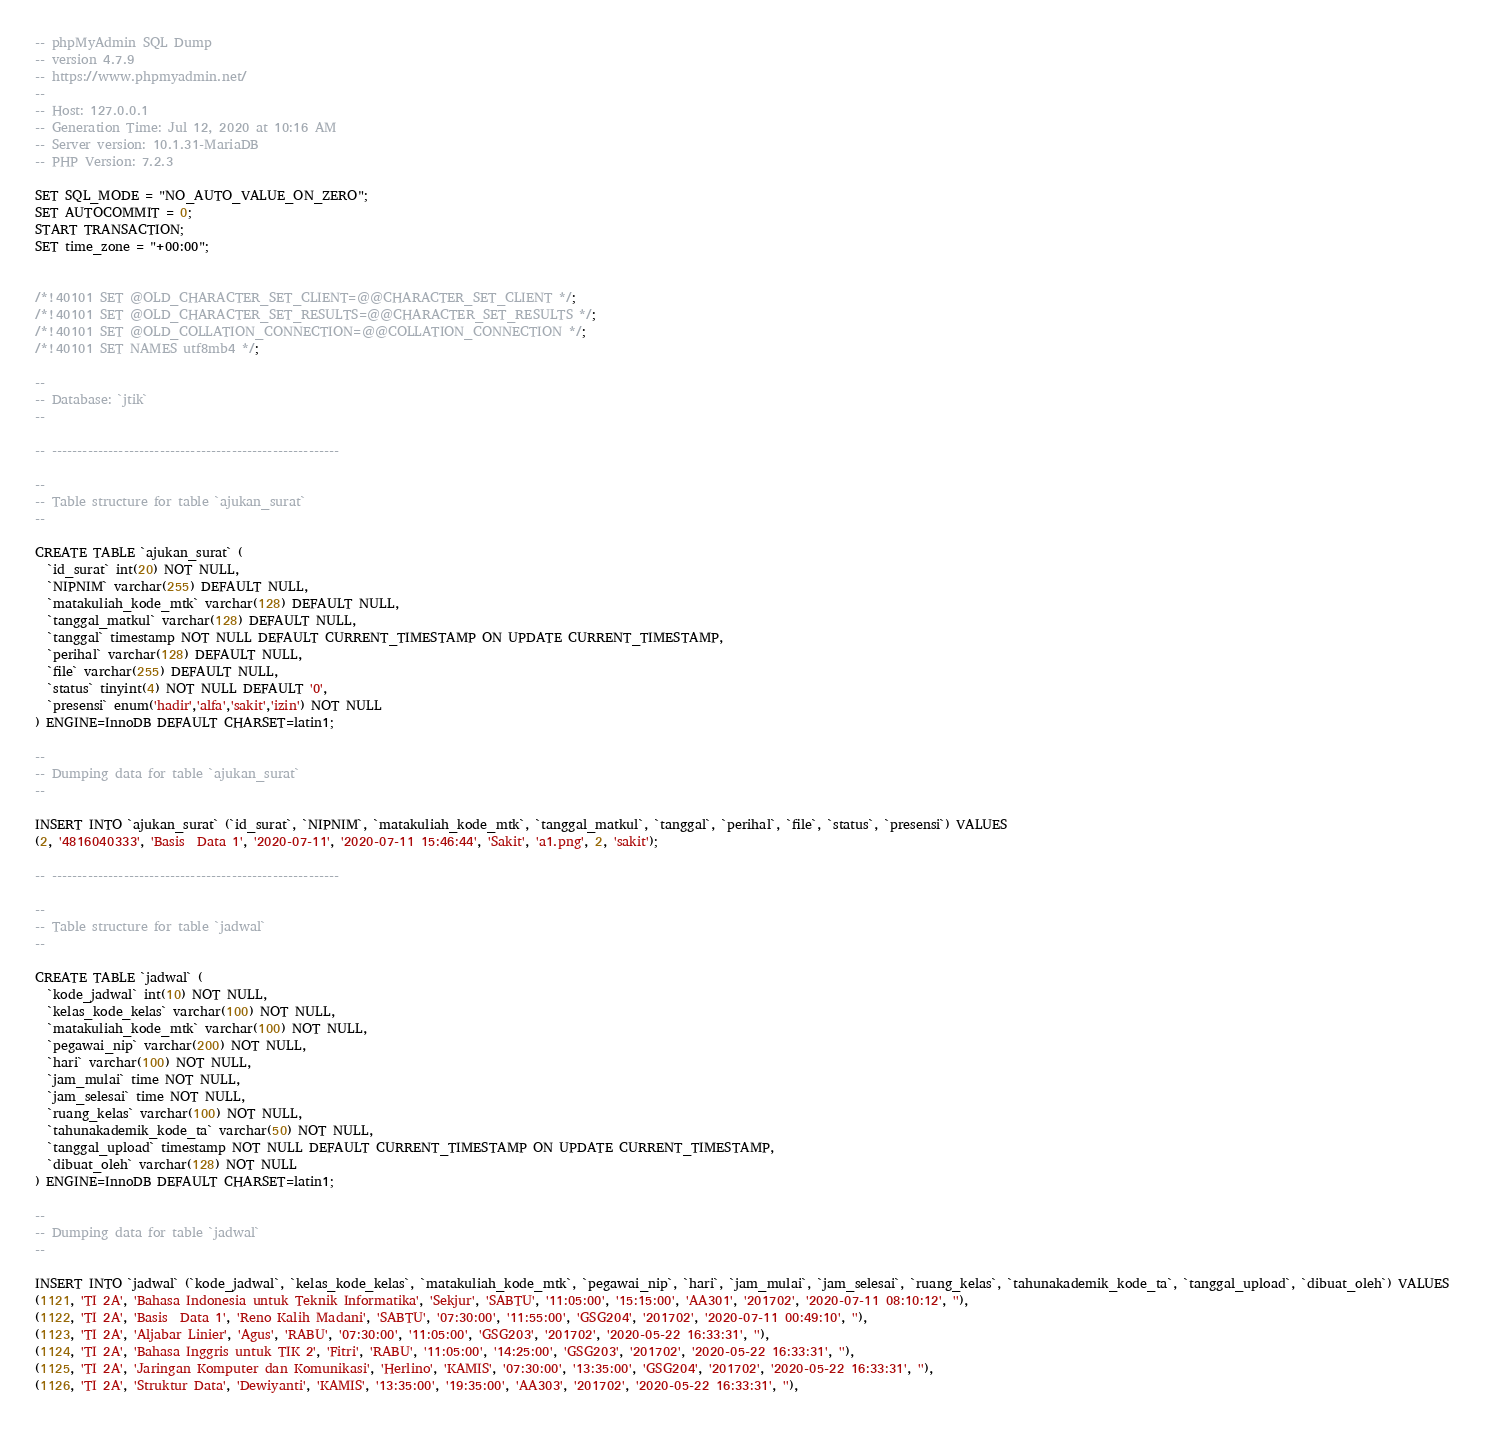Convert code to text. <code><loc_0><loc_0><loc_500><loc_500><_SQL_>-- phpMyAdmin SQL Dump
-- version 4.7.9
-- https://www.phpmyadmin.net/
--
-- Host: 127.0.0.1
-- Generation Time: Jul 12, 2020 at 10:16 AM
-- Server version: 10.1.31-MariaDB
-- PHP Version: 7.2.3

SET SQL_MODE = "NO_AUTO_VALUE_ON_ZERO";
SET AUTOCOMMIT = 0;
START TRANSACTION;
SET time_zone = "+00:00";


/*!40101 SET @OLD_CHARACTER_SET_CLIENT=@@CHARACTER_SET_CLIENT */;
/*!40101 SET @OLD_CHARACTER_SET_RESULTS=@@CHARACTER_SET_RESULTS */;
/*!40101 SET @OLD_COLLATION_CONNECTION=@@COLLATION_CONNECTION */;
/*!40101 SET NAMES utf8mb4 */;

--
-- Database: `jtik`
--

-- --------------------------------------------------------

--
-- Table structure for table `ajukan_surat`
--

CREATE TABLE `ajukan_surat` (
  `id_surat` int(20) NOT NULL,
  `NIPNIM` varchar(255) DEFAULT NULL,
  `matakuliah_kode_mtk` varchar(128) DEFAULT NULL,
  `tanggal_matkul` varchar(128) DEFAULT NULL,
  `tanggal` timestamp NOT NULL DEFAULT CURRENT_TIMESTAMP ON UPDATE CURRENT_TIMESTAMP,
  `perihal` varchar(128) DEFAULT NULL,
  `file` varchar(255) DEFAULT NULL,
  `status` tinyint(4) NOT NULL DEFAULT '0',
  `presensi` enum('hadir','alfa','sakit','izin') NOT NULL
) ENGINE=InnoDB DEFAULT CHARSET=latin1;

--
-- Dumping data for table `ajukan_surat`
--

INSERT INTO `ajukan_surat` (`id_surat`, `NIPNIM`, `matakuliah_kode_mtk`, `tanggal_matkul`, `tanggal`, `perihal`, `file`, `status`, `presensi`) VALUES
(2, '4816040333', 'Basis  Data 1', '2020-07-11', '2020-07-11 15:46:44', 'Sakit', 'a1.png', 2, 'sakit');

-- --------------------------------------------------------

--
-- Table structure for table `jadwal`
--

CREATE TABLE `jadwal` (
  `kode_jadwal` int(10) NOT NULL,
  `kelas_kode_kelas` varchar(100) NOT NULL,
  `matakuliah_kode_mtk` varchar(100) NOT NULL,
  `pegawai_nip` varchar(200) NOT NULL,
  `hari` varchar(100) NOT NULL,
  `jam_mulai` time NOT NULL,
  `jam_selesai` time NOT NULL,
  `ruang_kelas` varchar(100) NOT NULL,
  `tahunakademik_kode_ta` varchar(50) NOT NULL,
  `tanggal_upload` timestamp NOT NULL DEFAULT CURRENT_TIMESTAMP ON UPDATE CURRENT_TIMESTAMP,
  `dibuat_oleh` varchar(128) NOT NULL
) ENGINE=InnoDB DEFAULT CHARSET=latin1;

--
-- Dumping data for table `jadwal`
--

INSERT INTO `jadwal` (`kode_jadwal`, `kelas_kode_kelas`, `matakuliah_kode_mtk`, `pegawai_nip`, `hari`, `jam_mulai`, `jam_selesai`, `ruang_kelas`, `tahunakademik_kode_ta`, `tanggal_upload`, `dibuat_oleh`) VALUES
(1121, 'TI 2A', 'Bahasa Indonesia untuk Teknik Informatika', 'Sekjur', 'SABTU', '11:05:00', '15:15:00', 'AA301', '201702', '2020-07-11 08:10:12', ''),
(1122, 'TI 2A', 'Basis  Data 1', 'Reno Kalih Madani', 'SABTU', '07:30:00', '11:55:00', 'GSG204', '201702', '2020-07-11 00:49:10', ''),
(1123, 'TI 2A', 'Aljabar Linier', 'Agus', 'RABU', '07:30:00', '11:05:00', 'GSG203', '201702', '2020-05-22 16:33:31', ''),
(1124, 'TI 2A', 'Bahasa Inggris untuk TIK 2', 'Fitri', 'RABU', '11:05:00', '14:25:00', 'GSG203', '201702', '2020-05-22 16:33:31', ''),
(1125, 'TI 2A', 'Jaringan Komputer dan Komunikasi', 'Herlino', 'KAMIS', '07:30:00', '13:35:00', 'GSG204', '201702', '2020-05-22 16:33:31', ''),
(1126, 'TI 2A', 'Struktur Data', 'Dewiyanti', 'KAMIS', '13:35:00', '19:35:00', 'AA303', '201702', '2020-05-22 16:33:31', ''),</code> 